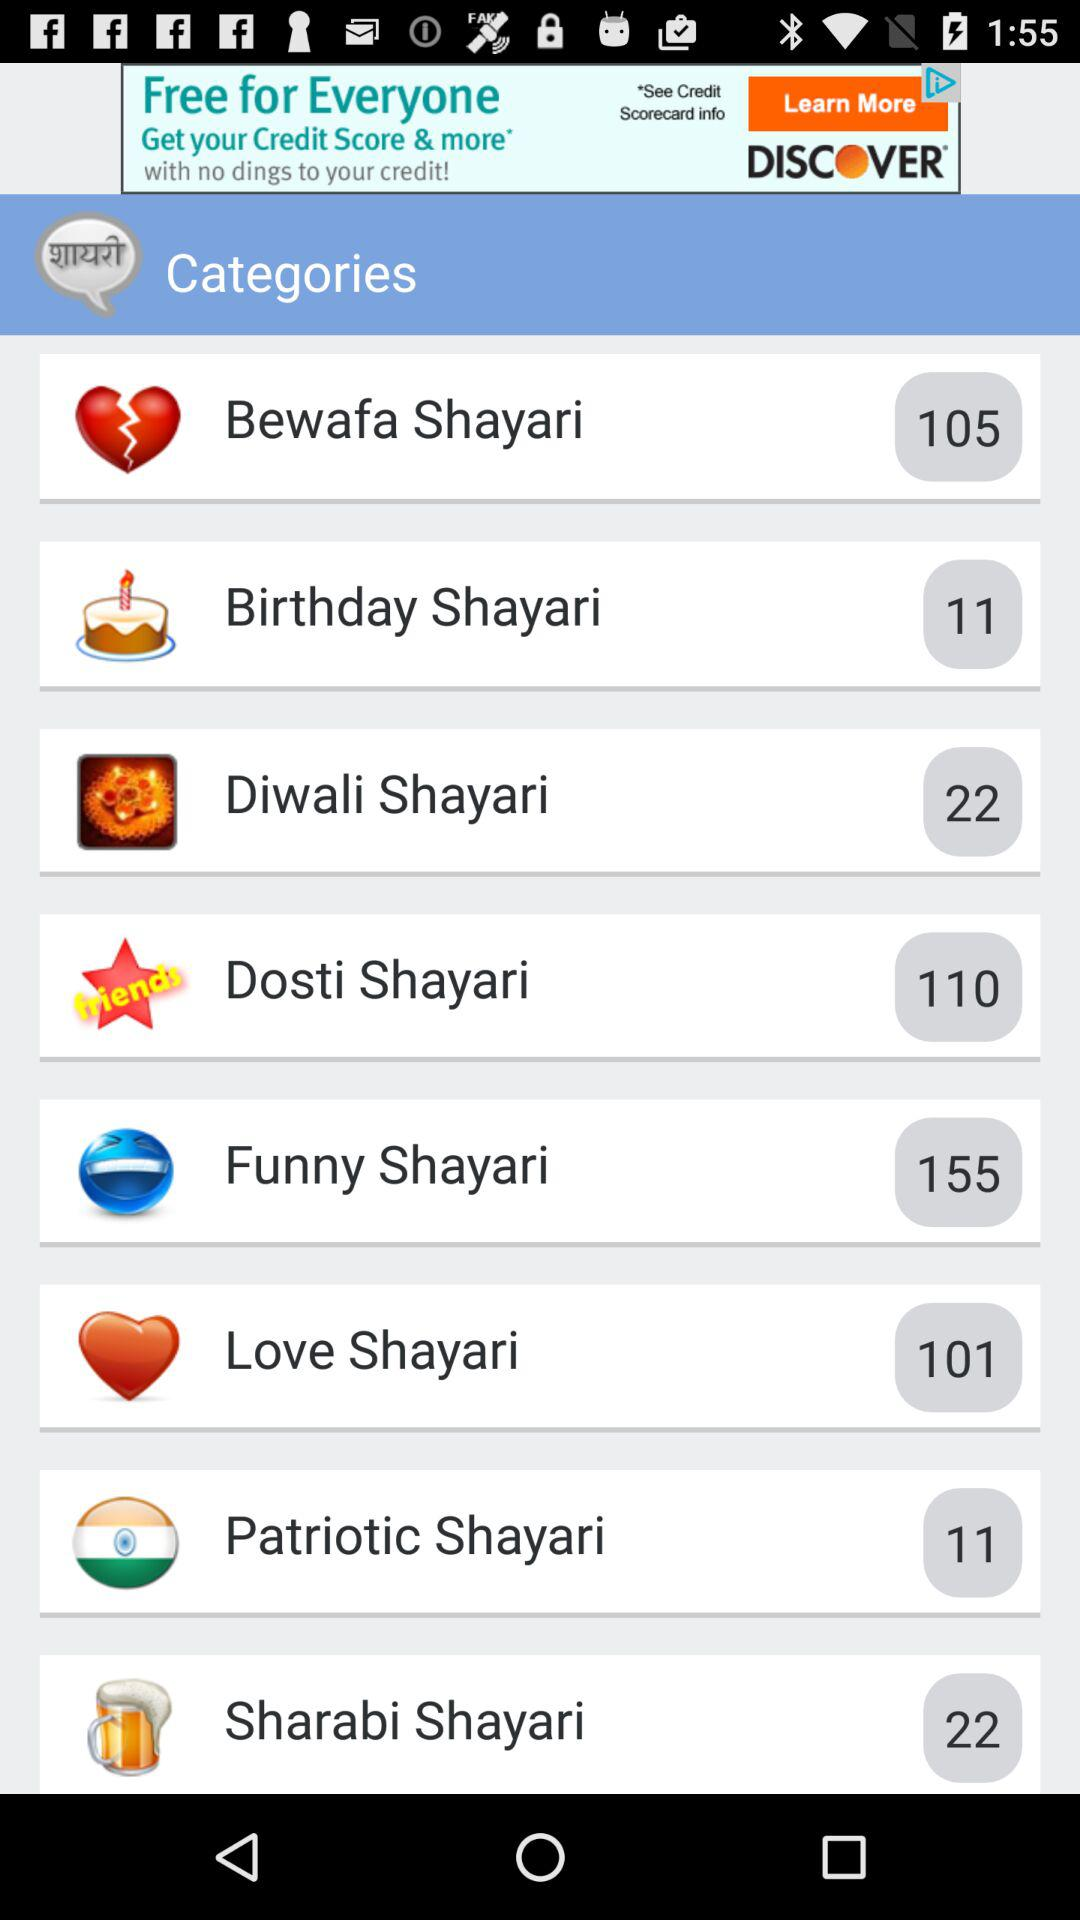How many categories are there in total?
Answer the question using a single word or phrase. 8 